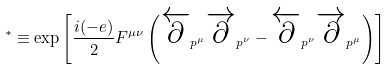Convert formula to latex. <formula><loc_0><loc_0><loc_500><loc_500>^ { * } \equiv \exp \left [ \frac { i ( - e ) } { 2 } F ^ { \mu \nu } \left ( \overleftarrow { \partial } _ { p ^ { \mu } } \overrightarrow { \partial } _ { p ^ { \nu } } - \overleftarrow { \partial } _ { p ^ { \nu } } \overrightarrow { \partial } _ { p ^ { \mu } } \right ) \right ]</formula> 